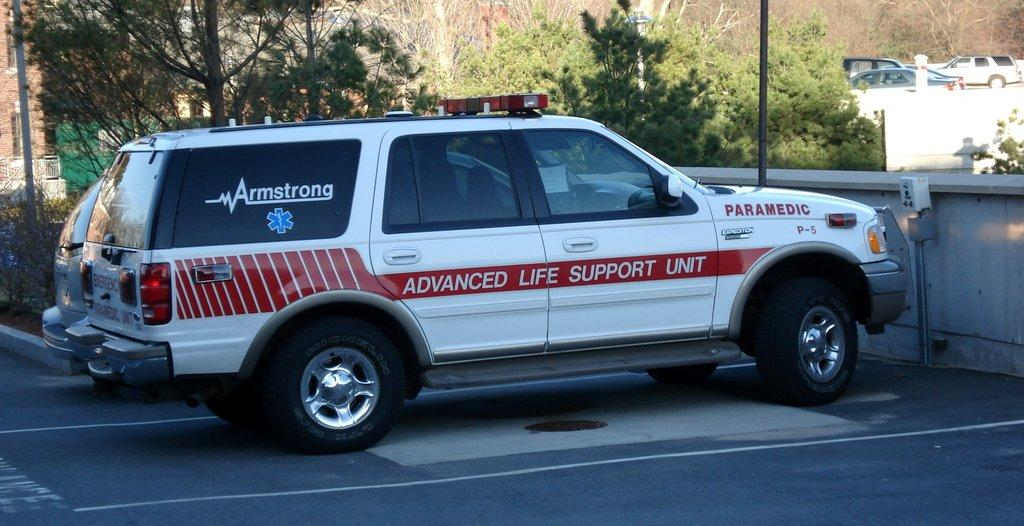What is the main subject of the image? The main subject of the image is a vehicle. Can you describe the color of the vehicle? The vehicle is white and red in color. What is written on the vehicle? The word "Armstrong" is written on the vehicle. What can be seen beside the vehicle? There are trees beside the vehicle. What else can be seen in the image? There are other vehicles in the right corner of the image. What type of creature is sitting on the hood of the vehicle in the image? There is: There is no creature sitting on the hood of the vehicle in the image. What is the chance of winning a prize if you play with the trucks in the image? There are no trucks or any mention of a prize in the image, so it's not possible to determine the chance of winning a prize. 